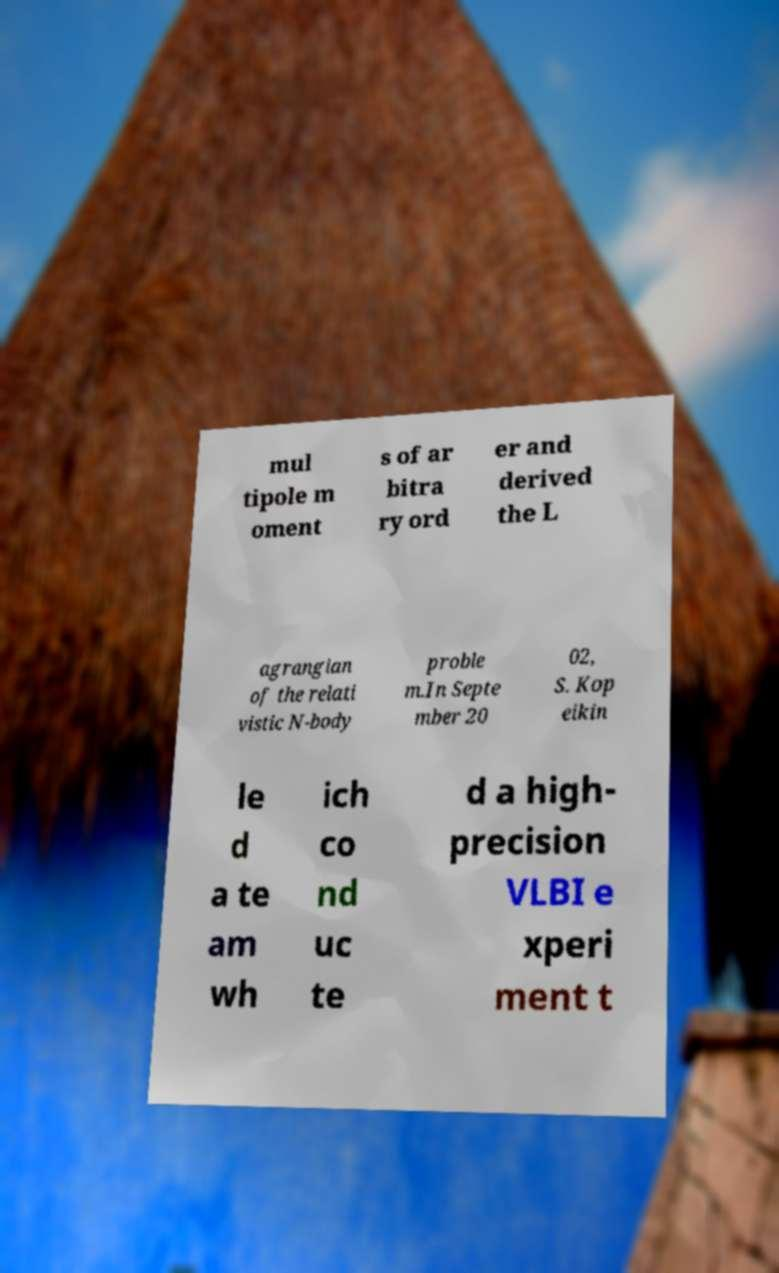For documentation purposes, I need the text within this image transcribed. Could you provide that? mul tipole m oment s of ar bitra ry ord er and derived the L agrangian of the relati vistic N-body proble m.In Septe mber 20 02, S. Kop eikin le d a te am wh ich co nd uc te d a high- precision VLBI e xperi ment t 